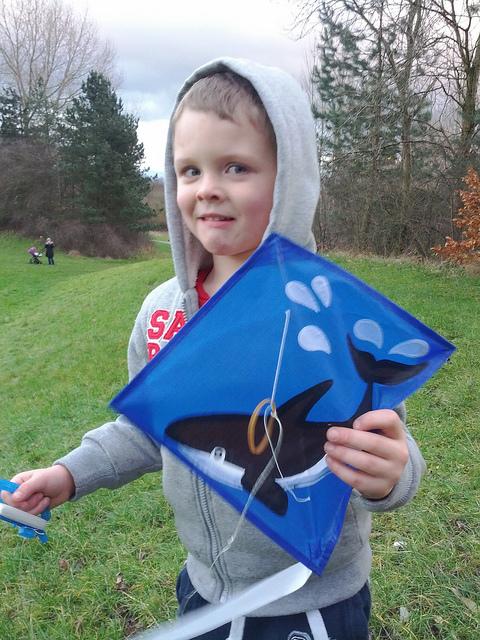Are there trees in the photo?
Be succinct. Yes. What animal is on the boy's kite?
Quick response, please. Whale. Is the boy smiling?
Short answer required. No. 